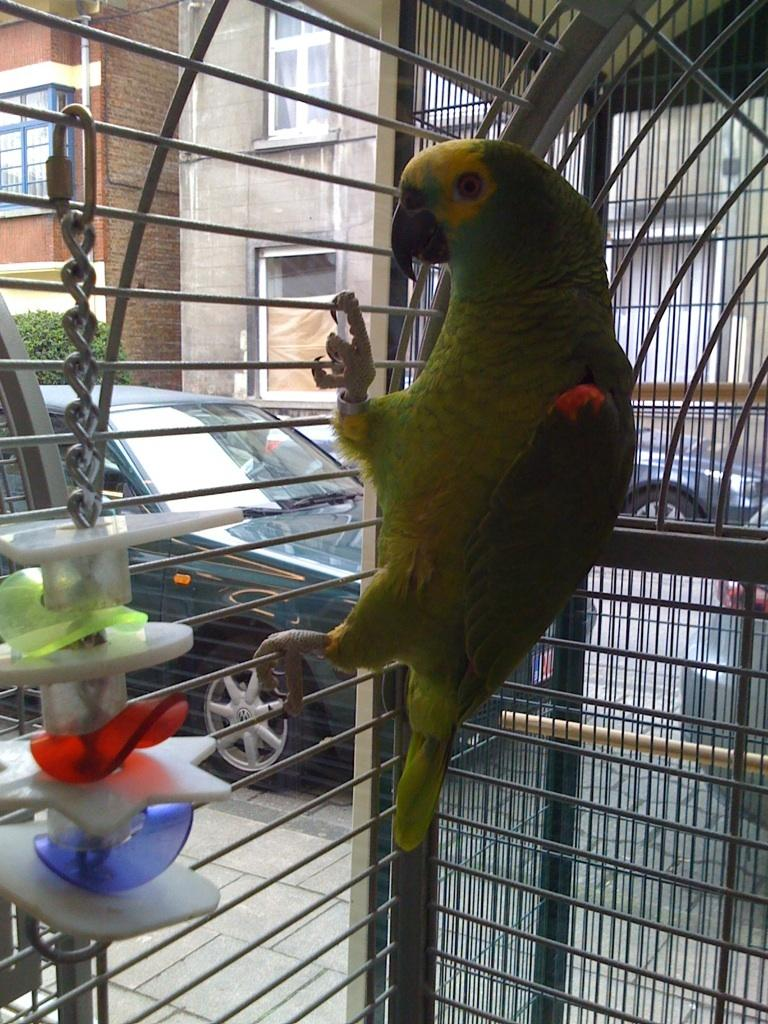What type of animal is in the cage in the image? There is a parrot in the cage in the image. What else can be seen inside the cage? There are objects in the cage. What can be seen in the background of the image? There are vehicles, buildings, plants, and other unspecified objects in the background of the image. What type of cabbage is being used as a shoe in the image? There is no cabbage or shoe present in the image. How many docks can be seen in the image? There are no docks present in the image. 